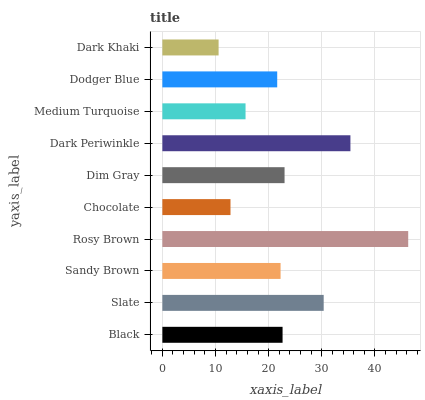Is Dark Khaki the minimum?
Answer yes or no. Yes. Is Rosy Brown the maximum?
Answer yes or no. Yes. Is Slate the minimum?
Answer yes or no. No. Is Slate the maximum?
Answer yes or no. No. Is Slate greater than Black?
Answer yes or no. Yes. Is Black less than Slate?
Answer yes or no. Yes. Is Black greater than Slate?
Answer yes or no. No. Is Slate less than Black?
Answer yes or no. No. Is Black the high median?
Answer yes or no. Yes. Is Sandy Brown the low median?
Answer yes or no. Yes. Is Dark Periwinkle the high median?
Answer yes or no. No. Is Medium Turquoise the low median?
Answer yes or no. No. 